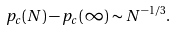Convert formula to latex. <formula><loc_0><loc_0><loc_500><loc_500>p _ { c } ( N ) - p _ { c } ( \infty ) \sim N ^ { - 1 / 3 } .</formula> 